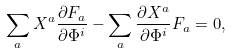Convert formula to latex. <formula><loc_0><loc_0><loc_500><loc_500>\sum _ { a } X ^ { a } \frac { \partial F _ { a } } { \partial \Phi ^ { i } } - \sum _ { a } \frac { \partial X ^ { a } } { \partial \Phi ^ { i } } F _ { a } = 0 ,</formula> 